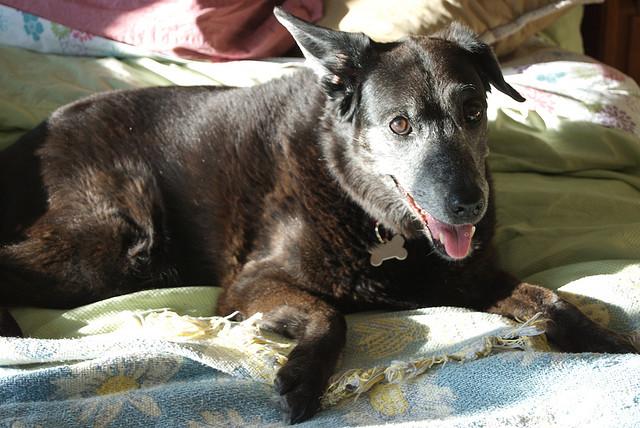What kind of tag is he wearing?
Short answer required. Bone. Is the sun shining?
Answer briefly. Yes. How many blankets are under the dog?
Short answer required. 2. 